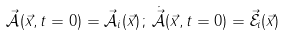Convert formula to latex. <formula><loc_0><loc_0><loc_500><loc_500>\vec { \mathcal { A } } ( \vec { x } , t = 0 ) = \vec { \mathcal { A } } _ { i } ( \vec { x } ) \, ; \, \dot { \vec { \mathcal { A } } } ( \vec { x } , t = 0 ) = \vec { \mathcal { E } } _ { i } ( \vec { x } )</formula> 